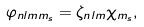<formula> <loc_0><loc_0><loc_500><loc_500>\varphi _ { n l m m _ { s } } = \zeta _ { n l m } \chi _ { m _ { s } } ,</formula> 